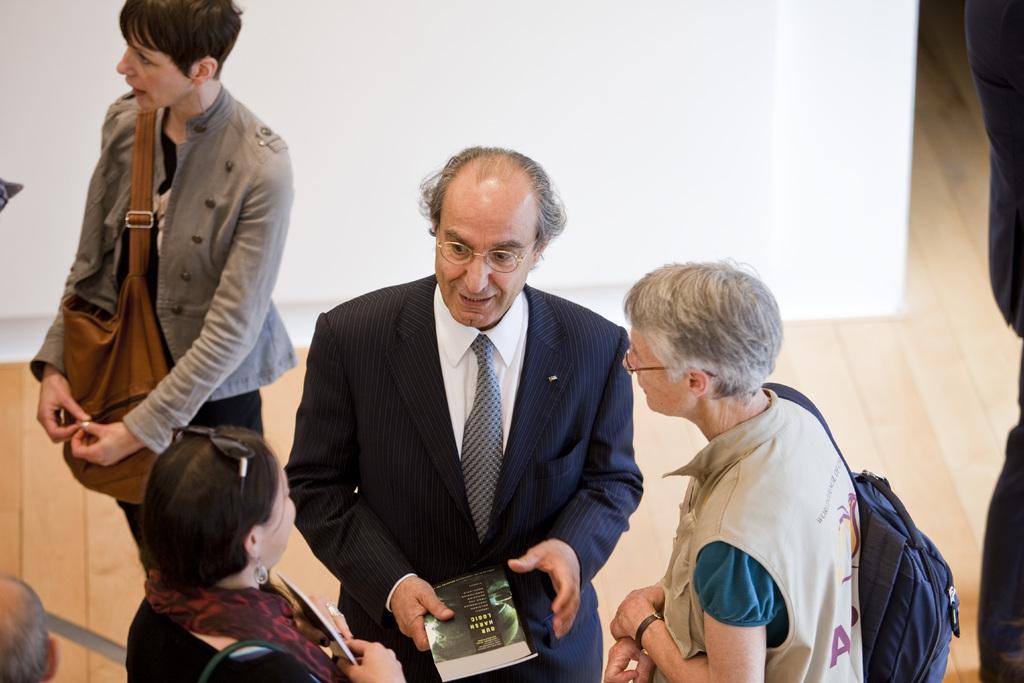In one or two sentences, can you explain what this image depicts? There is a person wearing suit, shirt, tie and holding a book. In front of him, there are two women who are listening to him. In the background, there is a white color wall. 